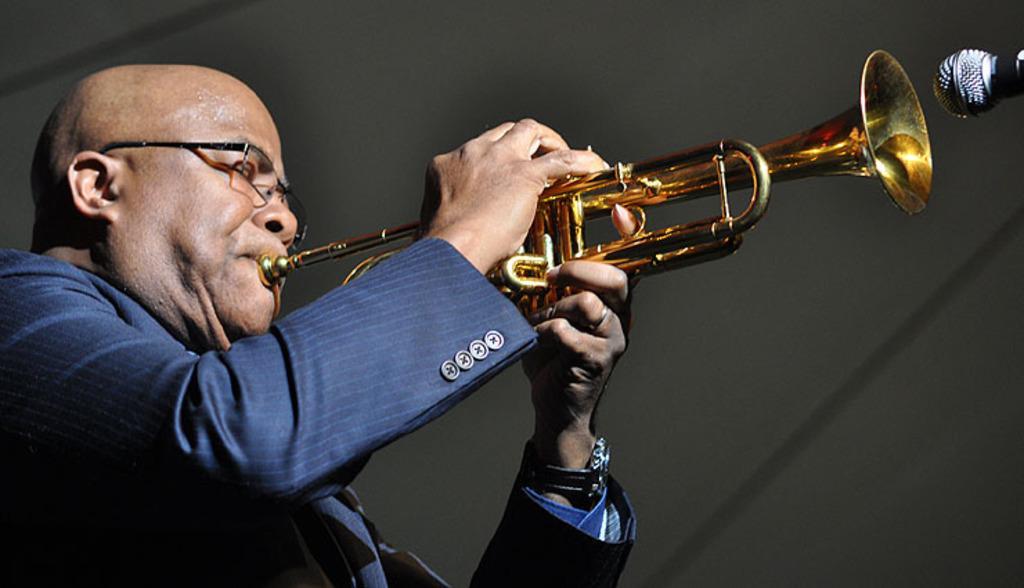Could you give a brief overview of what you see in this image? As we can see in the image there is a person wearing blue color jacket and holding musical instrument. On the right side there is a mic. 